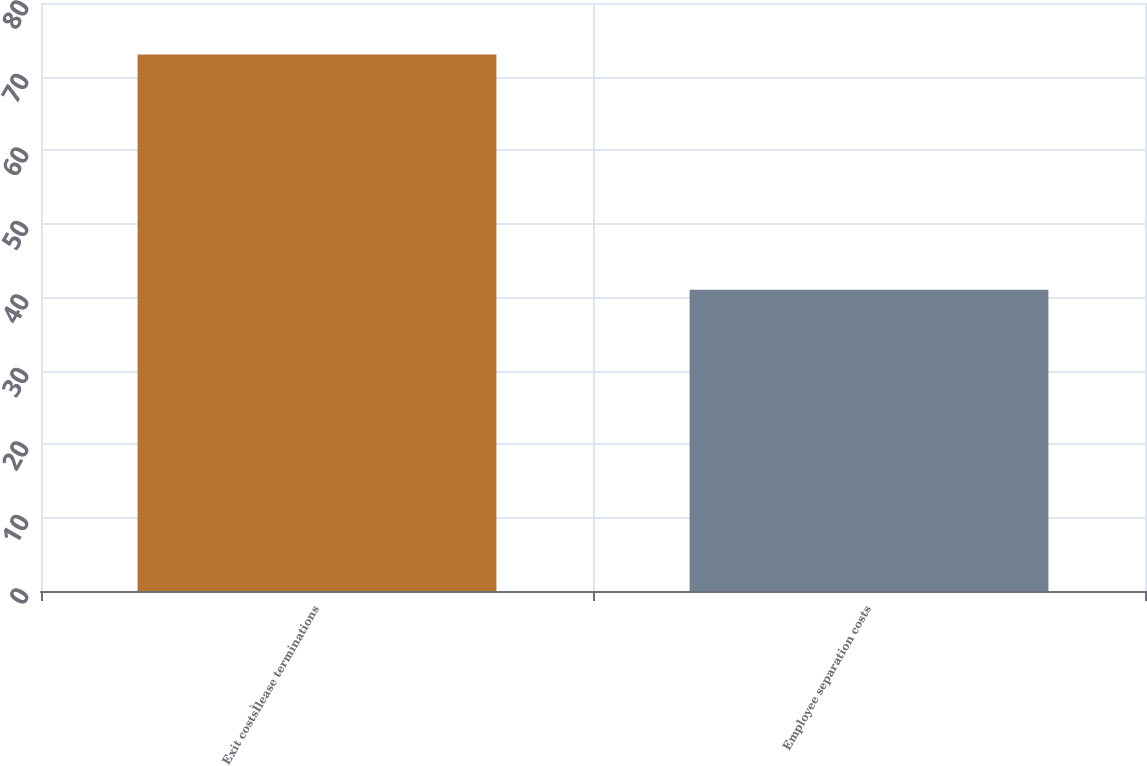<chart> <loc_0><loc_0><loc_500><loc_500><bar_chart><fcel>Exit costsÌlease terminations<fcel>Employee separation costs<nl><fcel>73<fcel>41<nl></chart> 